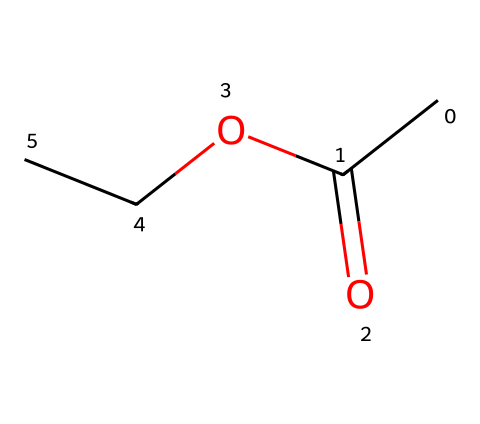What is the molecular formula of ethyl acetate? The molecular formula can be derived from counting the atoms in the structure. The ethyl acetate structure represented by the SMILES shows two carbon atoms from the ethyl group (CC), two oxygen atoms (O), and four hydrogen atoms (H). Hence, the molecular formula is C4H8O2.
Answer: C4H8O2 How many carbon atoms are present in ethyl acetate? By examining the SMILES notation, we identify the ethyl group CC contributes two carbon atoms, and one carbon is connected to the carbonyl group (=O) making a total of two carbon atoms from the structure.
Answer: 4 What type of functional groups are seen in ethyl acetate? Analyzing the structure reveals the presence of both an ester and a carbonyl functional group. The -OCC portion indicates an ester bond, while the C(=O) indicates a carbonyl group. Hence, both groups are present in this molecule.
Answer: ester, carbonyl What is the general property of esters like ethyl acetate regarding odor? Esters are well-known for having pleasant fragrances, often described as fruity. Ethyl acetate, in particular, is often used for its sweet smell, which contributes to its application in cleaning and flavoring.
Answer: fruity How does the structure of ethyl acetate suggest its use as a solvent for cleaning? The presence of both polar and non-polar characteristics in its structure (due to the ether and carbonyl groups) indicates good solubility in various organic compounds. This dual nature enhances its performance as a solvent for cleaning sports equipment.
Answer: polar and non-polar characteristics What is the significance of the ester bond in ethyl acetate? The ester bond is responsible for the chemical properties of ethyl acetate, including its volatility and ability to dissolve certain substances. This is crucial for its function as a solvent in various applications, such as cleaning.
Answer: chemical properties Is ethyl acetate a polar or non-polar solvent? Considering the structure, the presence of the polar carbonyl (C=O) group in combination with the ethyl group produces an overall polar character, thus classifying ethyl acetate as a polar solvent, although it has some non-polar characteristics due to the ethyl tail.
Answer: polar 